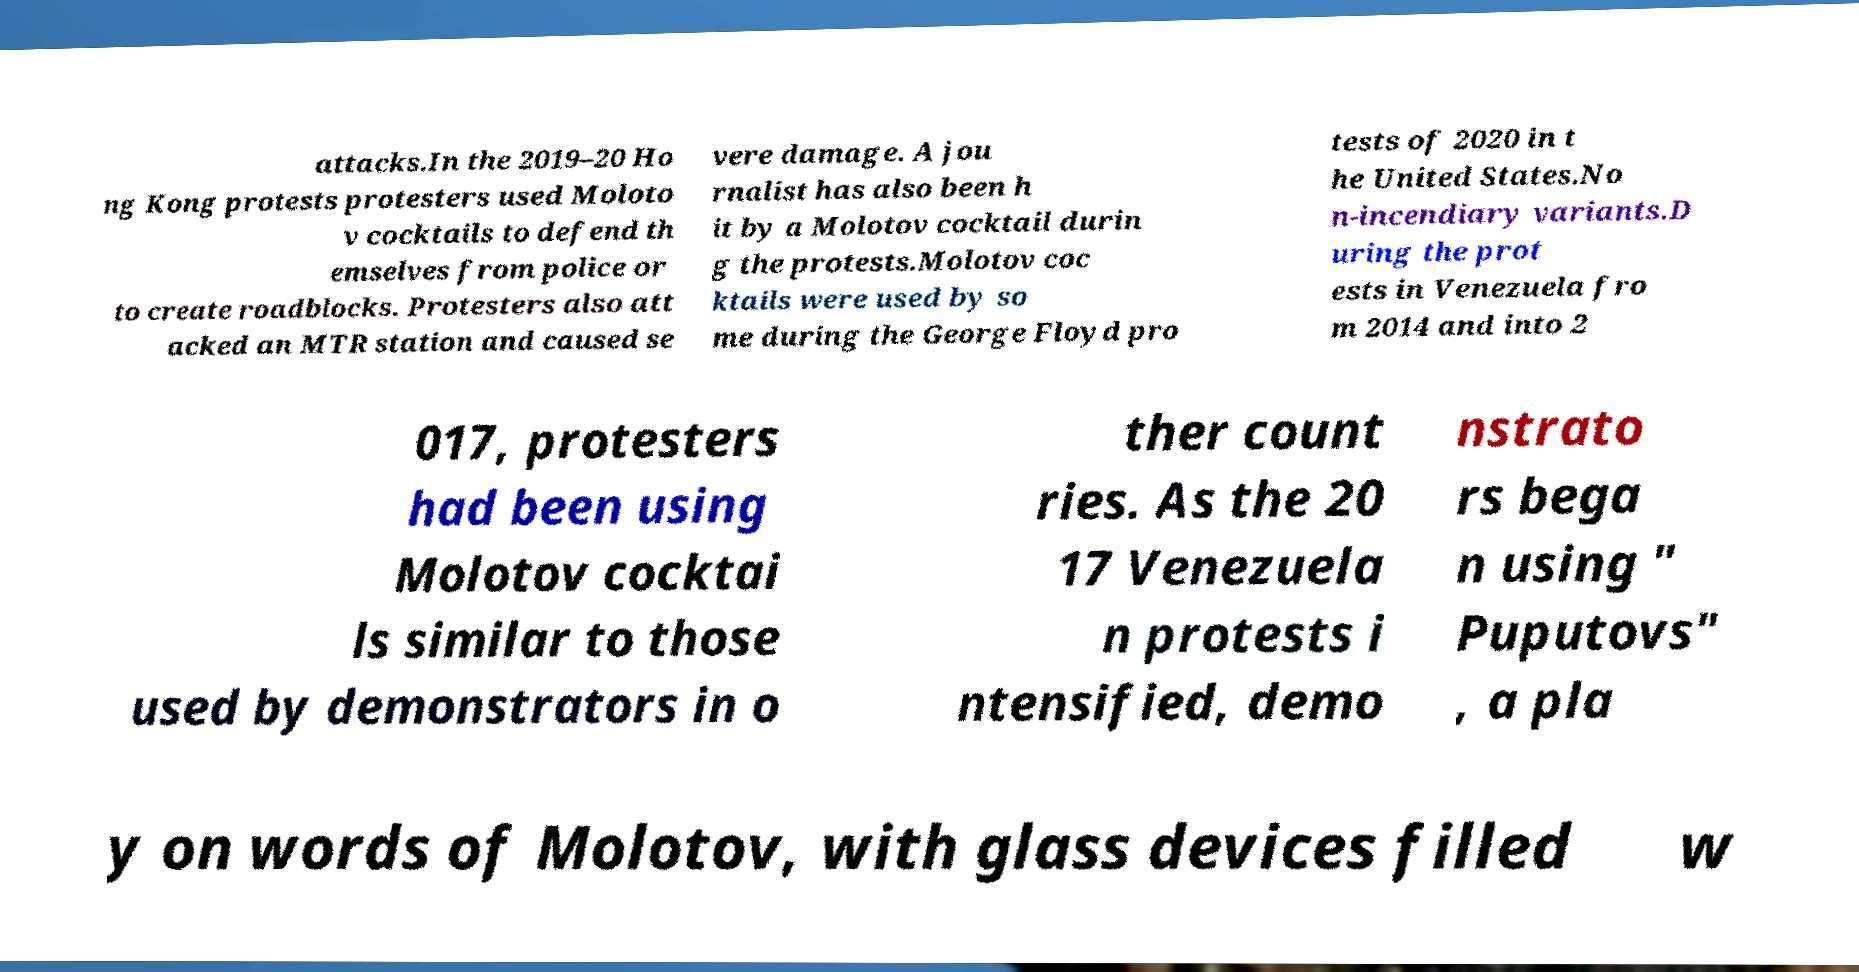There's text embedded in this image that I need extracted. Can you transcribe it verbatim? attacks.In the 2019–20 Ho ng Kong protests protesters used Moloto v cocktails to defend th emselves from police or to create roadblocks. Protesters also att acked an MTR station and caused se vere damage. A jou rnalist has also been h it by a Molotov cocktail durin g the protests.Molotov coc ktails were used by so me during the George Floyd pro tests of 2020 in t he United States.No n-incendiary variants.D uring the prot ests in Venezuela fro m 2014 and into 2 017, protesters had been using Molotov cocktai ls similar to those used by demonstrators in o ther count ries. As the 20 17 Venezuela n protests i ntensified, demo nstrato rs bega n using " Puputovs" , a pla y on words of Molotov, with glass devices filled w 